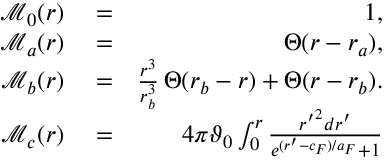<formula> <loc_0><loc_0><loc_500><loc_500>\begin{array} { r l r } { \mathcal { M } _ { 0 } ( r ) } & = } & { 1 , } \\ { \mathcal { M } _ { a } ( r ) } & = } & { \Theta ( r - r _ { a } ) , } \\ { \mathcal { M } _ { b } ( r ) } & = } & { \frac { r ^ { 3 } } { r _ { b } ^ { 3 } } \, \Theta ( r _ { b } - r ) + \Theta ( r - r _ { b } ) . } \\ { \mathcal { M } _ { c } ( r ) } & = } & { 4 \pi \vartheta _ { 0 } \int _ { 0 } ^ { r } \frac { { r ^ { \prime } } ^ { 2 } d r ^ { \prime } } { e ^ { ( r ^ { \prime } - c _ { F } ) / a _ { F } } + 1 } } \end{array}</formula> 